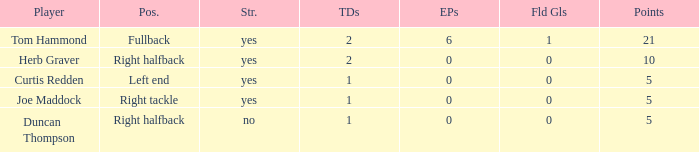Name the most touchdowns for field goals being 1 2.0. 